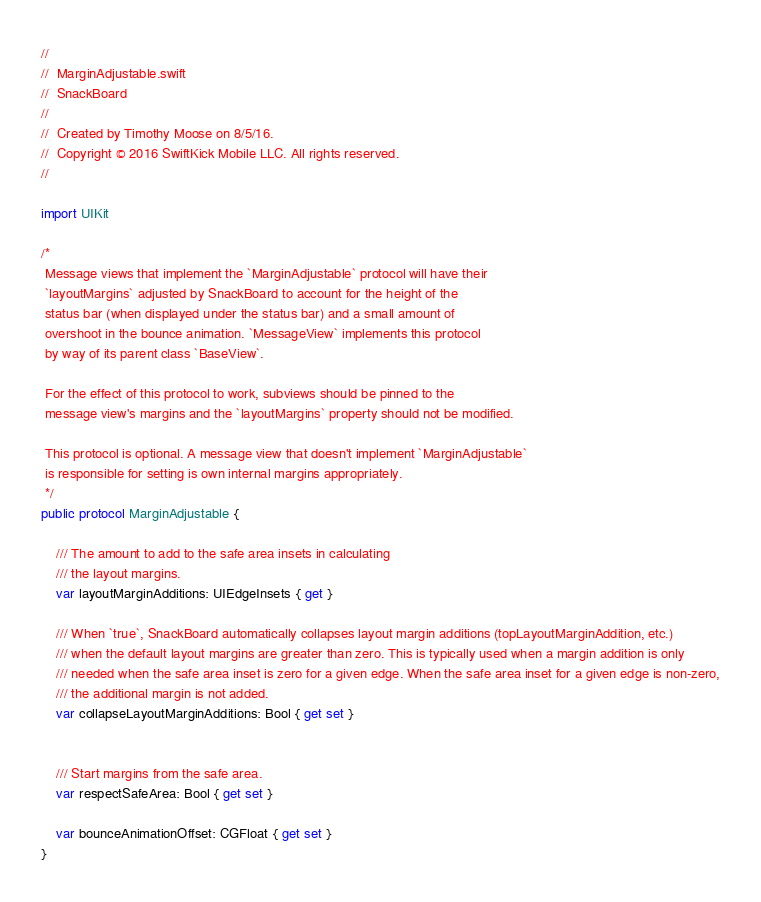Convert code to text. <code><loc_0><loc_0><loc_500><loc_500><_Swift_>//
//  MarginAdjustable.swift
//  SnackBoard
//
//  Created by Timothy Moose on 8/5/16.
//  Copyright © 2016 SwiftKick Mobile LLC. All rights reserved.
//

import UIKit

/*
 Message views that implement the `MarginAdjustable` protocol will have their
 `layoutMargins` adjusted by SnackBoard to account for the height of the
 status bar (when displayed under the status bar) and a small amount of
 overshoot in the bounce animation. `MessageView` implements this protocol
 by way of its parent class `BaseView`.
 
 For the effect of this protocol to work, subviews should be pinned to the
 message view's margins and the `layoutMargins` property should not be modified.
 
 This protocol is optional. A message view that doesn't implement `MarginAdjustable`
 is responsible for setting is own internal margins appropriately.
 */
public protocol MarginAdjustable {

    /// The amount to add to the safe area insets in calculating
    /// the layout margins.
    var layoutMarginAdditions: UIEdgeInsets { get }

    /// When `true`, SnackBoard automatically collapses layout margin additions (topLayoutMarginAddition, etc.)
    /// when the default layout margins are greater than zero. This is typically used when a margin addition is only
    /// needed when the safe area inset is zero for a given edge. When the safe area inset for a given edge is non-zero,
    /// the additional margin is not added.
    var collapseLayoutMarginAdditions: Bool { get set }


    /// Start margins from the safe area.
    var respectSafeArea: Bool { get set }

    var bounceAnimationOffset: CGFloat { get set }
}

</code> 